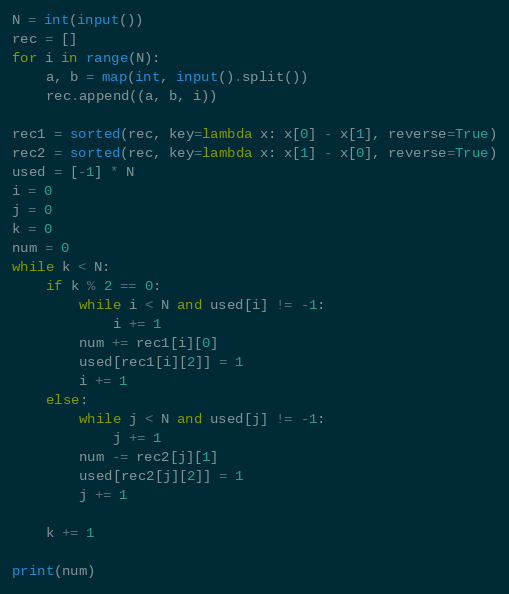<code> <loc_0><loc_0><loc_500><loc_500><_Python_>N = int(input())
rec = []
for i in range(N):
    a, b = map(int, input().split())
    rec.append((a, b, i))

rec1 = sorted(rec, key=lambda x: x[0] - x[1], reverse=True)
rec2 = sorted(rec, key=lambda x: x[1] - x[0], reverse=True)
used = [-1] * N
i = 0
j = 0
k = 0
num = 0
while k < N:
    if k % 2 == 0:
        while i < N and used[i] != -1:
            i += 1
        num += rec1[i][0]
        used[rec1[i][2]] = 1
        i += 1
    else:
        while j < N and used[j] != -1:
            j += 1
        num -= rec2[j][1]
        used[rec2[j][2]] = 1
        j += 1

    k += 1

print(num)</code> 